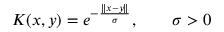Convert formula to latex. <formula><loc_0><loc_0><loc_500><loc_500>K ( x , y ) = e ^ { - { \frac { \| x - y \| } { \sigma } } } , \quad \sigma > 0</formula> 